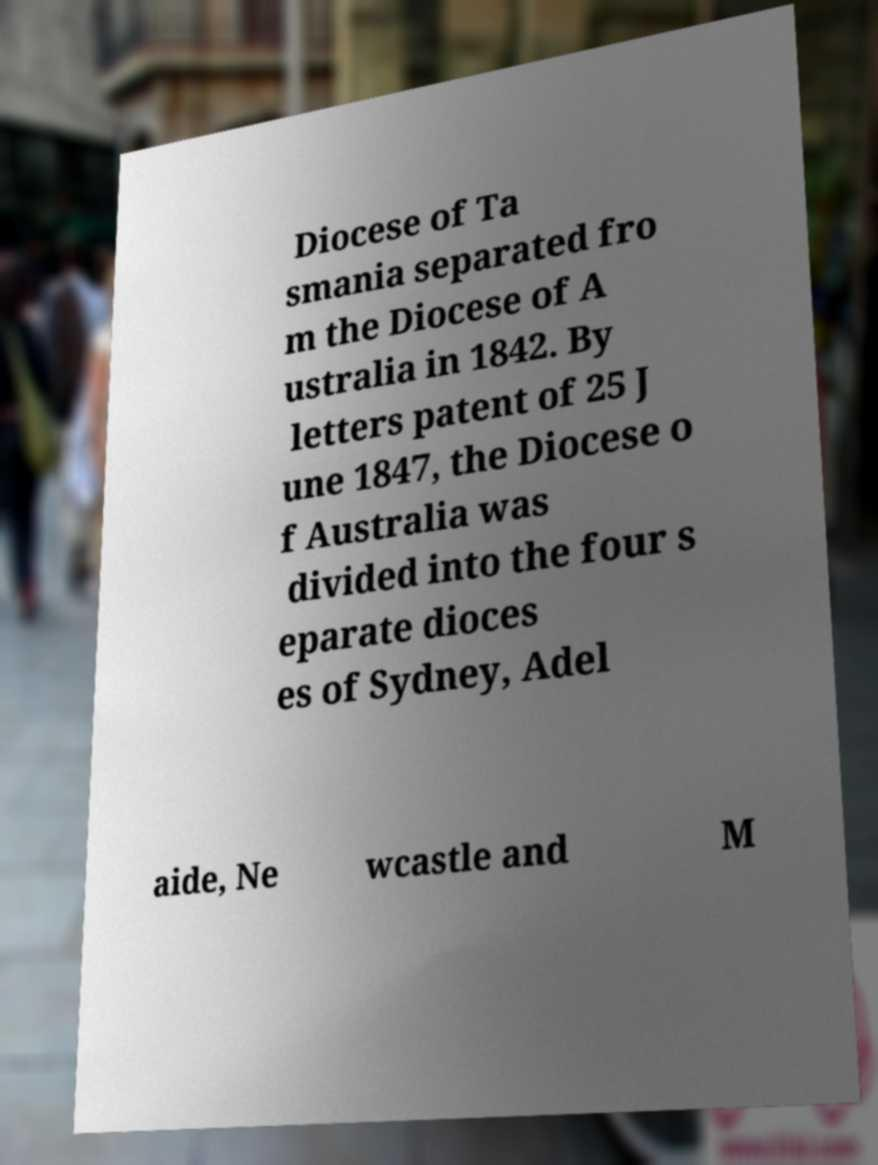Please identify and transcribe the text found in this image. Diocese of Ta smania separated fro m the Diocese of A ustralia in 1842. By letters patent of 25 J une 1847, the Diocese o f Australia was divided into the four s eparate dioces es of Sydney, Adel aide, Ne wcastle and M 